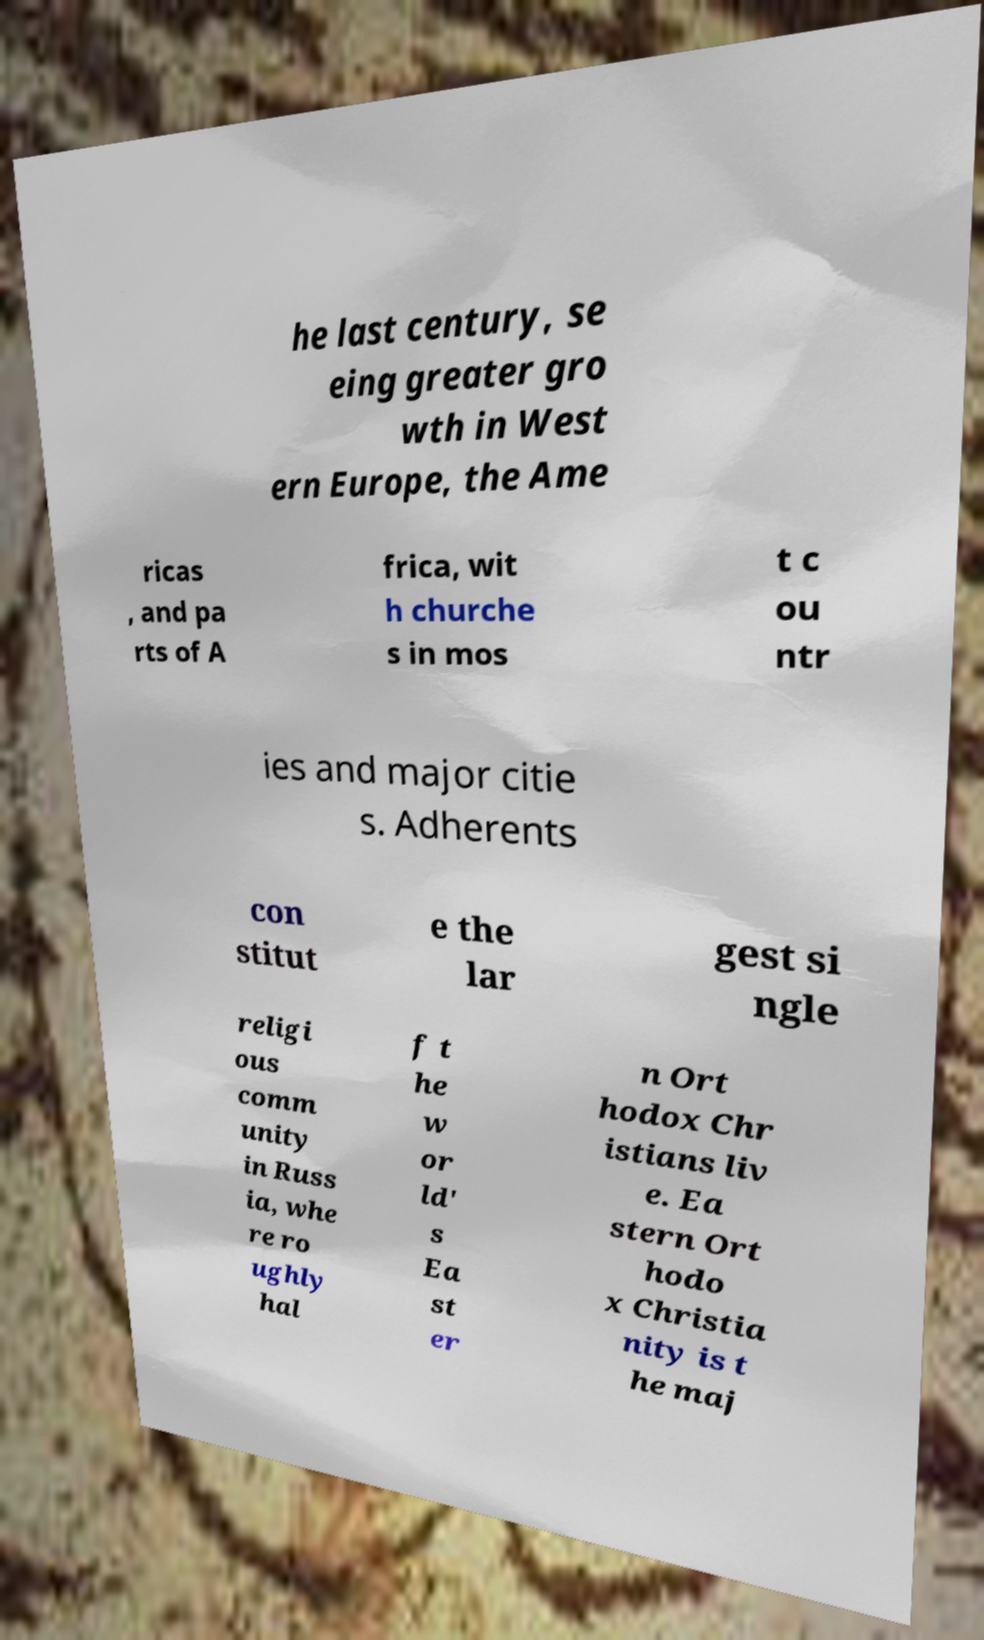Can you read and provide the text displayed in the image?This photo seems to have some interesting text. Can you extract and type it out for me? he last century, se eing greater gro wth in West ern Europe, the Ame ricas , and pa rts of A frica, wit h churche s in mos t c ou ntr ies and major citie s. Adherents con stitut e the lar gest si ngle religi ous comm unity in Russ ia, whe re ro ughly hal f t he w or ld' s Ea st er n Ort hodox Chr istians liv e. Ea stern Ort hodo x Christia nity is t he maj 